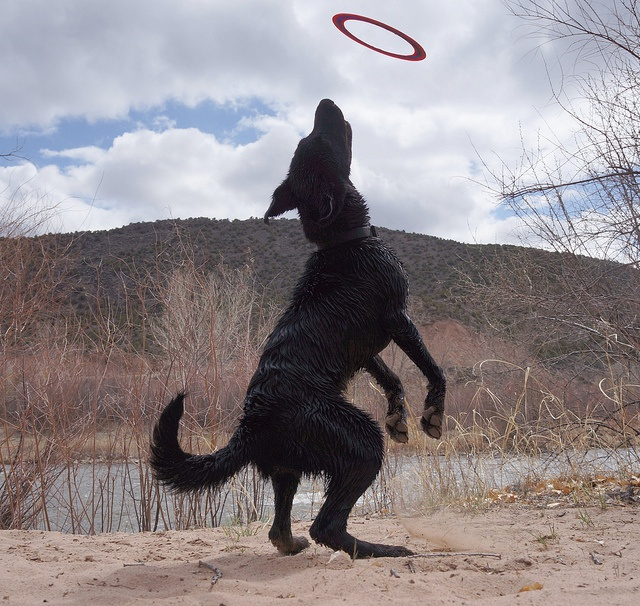Describe the objects in this image and their specific colors. I can see dog in darkgray, black, and gray tones and frisbee in darkgray, lavender, purple, and brown tones in this image. 